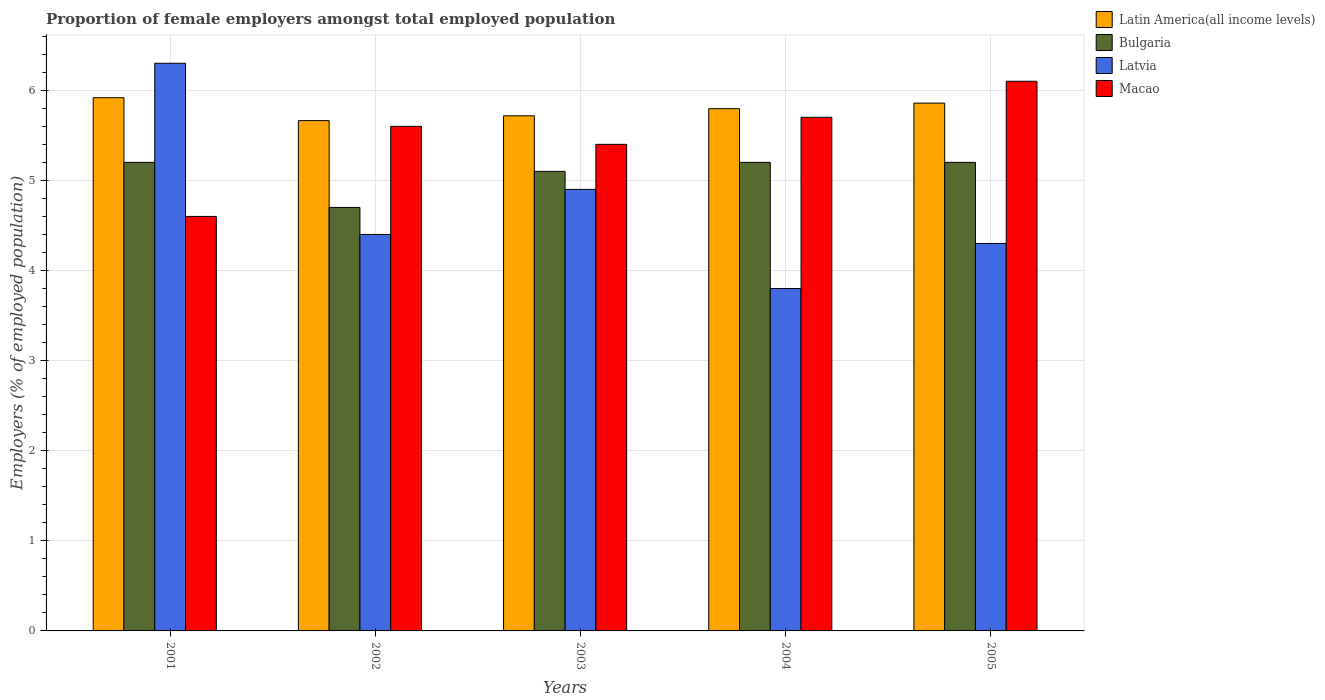Are the number of bars on each tick of the X-axis equal?
Give a very brief answer. Yes. In how many cases, is the number of bars for a given year not equal to the number of legend labels?
Make the answer very short. 0. What is the proportion of female employers in Bulgaria in 2003?
Offer a terse response. 5.1. Across all years, what is the maximum proportion of female employers in Latvia?
Keep it short and to the point. 6.3. Across all years, what is the minimum proportion of female employers in Latvia?
Provide a succinct answer. 3.8. In which year was the proportion of female employers in Bulgaria maximum?
Offer a terse response. 2001. In which year was the proportion of female employers in Latvia minimum?
Give a very brief answer. 2004. What is the total proportion of female employers in Macao in the graph?
Offer a very short reply. 27.4. What is the difference between the proportion of female employers in Latvia in 2005 and the proportion of female employers in Latin America(all income levels) in 2004?
Offer a very short reply. -1.5. What is the average proportion of female employers in Bulgaria per year?
Make the answer very short. 5.08. In the year 2002, what is the difference between the proportion of female employers in Macao and proportion of female employers in Latvia?
Your answer should be very brief. 1.2. In how many years, is the proportion of female employers in Latvia greater than 2.2 %?
Ensure brevity in your answer.  5. What is the ratio of the proportion of female employers in Macao in 2002 to that in 2004?
Keep it short and to the point. 0.98. What is the difference between the highest and the second highest proportion of female employers in Latin America(all income levels)?
Offer a terse response. 0.06. In how many years, is the proportion of female employers in Bulgaria greater than the average proportion of female employers in Bulgaria taken over all years?
Your answer should be very brief. 4. Is the sum of the proportion of female employers in Latin America(all income levels) in 2001 and 2004 greater than the maximum proportion of female employers in Macao across all years?
Your answer should be compact. Yes. What does the 1st bar from the right in 2001 represents?
Provide a short and direct response. Macao. Is it the case that in every year, the sum of the proportion of female employers in Latin America(all income levels) and proportion of female employers in Macao is greater than the proportion of female employers in Latvia?
Make the answer very short. Yes. How many bars are there?
Offer a terse response. 20. Are the values on the major ticks of Y-axis written in scientific E-notation?
Your response must be concise. No. Does the graph contain any zero values?
Offer a very short reply. No. Does the graph contain grids?
Provide a succinct answer. Yes. Where does the legend appear in the graph?
Your answer should be compact. Top right. What is the title of the graph?
Keep it short and to the point. Proportion of female employers amongst total employed population. What is the label or title of the Y-axis?
Provide a succinct answer. Employers (% of employed population). What is the Employers (% of employed population) of Latin America(all income levels) in 2001?
Ensure brevity in your answer.  5.92. What is the Employers (% of employed population) in Bulgaria in 2001?
Your answer should be very brief. 5.2. What is the Employers (% of employed population) of Latvia in 2001?
Keep it short and to the point. 6.3. What is the Employers (% of employed population) in Macao in 2001?
Offer a very short reply. 4.6. What is the Employers (% of employed population) of Latin America(all income levels) in 2002?
Provide a succinct answer. 5.66. What is the Employers (% of employed population) in Bulgaria in 2002?
Offer a very short reply. 4.7. What is the Employers (% of employed population) in Latvia in 2002?
Keep it short and to the point. 4.4. What is the Employers (% of employed population) in Macao in 2002?
Offer a very short reply. 5.6. What is the Employers (% of employed population) in Latin America(all income levels) in 2003?
Make the answer very short. 5.72. What is the Employers (% of employed population) of Bulgaria in 2003?
Ensure brevity in your answer.  5.1. What is the Employers (% of employed population) in Latvia in 2003?
Provide a succinct answer. 4.9. What is the Employers (% of employed population) of Macao in 2003?
Provide a succinct answer. 5.4. What is the Employers (% of employed population) in Latin America(all income levels) in 2004?
Provide a short and direct response. 5.8. What is the Employers (% of employed population) of Bulgaria in 2004?
Your answer should be compact. 5.2. What is the Employers (% of employed population) of Latvia in 2004?
Your answer should be very brief. 3.8. What is the Employers (% of employed population) of Macao in 2004?
Make the answer very short. 5.7. What is the Employers (% of employed population) in Latin America(all income levels) in 2005?
Offer a very short reply. 5.86. What is the Employers (% of employed population) of Bulgaria in 2005?
Offer a terse response. 5.2. What is the Employers (% of employed population) of Latvia in 2005?
Keep it short and to the point. 4.3. What is the Employers (% of employed population) of Macao in 2005?
Give a very brief answer. 6.1. Across all years, what is the maximum Employers (% of employed population) in Latin America(all income levels)?
Your answer should be very brief. 5.92. Across all years, what is the maximum Employers (% of employed population) in Bulgaria?
Give a very brief answer. 5.2. Across all years, what is the maximum Employers (% of employed population) in Latvia?
Ensure brevity in your answer.  6.3. Across all years, what is the maximum Employers (% of employed population) of Macao?
Make the answer very short. 6.1. Across all years, what is the minimum Employers (% of employed population) of Latin America(all income levels)?
Offer a very short reply. 5.66. Across all years, what is the minimum Employers (% of employed population) of Bulgaria?
Provide a short and direct response. 4.7. Across all years, what is the minimum Employers (% of employed population) in Latvia?
Give a very brief answer. 3.8. Across all years, what is the minimum Employers (% of employed population) of Macao?
Provide a short and direct response. 4.6. What is the total Employers (% of employed population) of Latin America(all income levels) in the graph?
Provide a short and direct response. 28.95. What is the total Employers (% of employed population) in Bulgaria in the graph?
Your answer should be very brief. 25.4. What is the total Employers (% of employed population) of Latvia in the graph?
Your response must be concise. 23.7. What is the total Employers (% of employed population) in Macao in the graph?
Your answer should be compact. 27.4. What is the difference between the Employers (% of employed population) in Latin America(all income levels) in 2001 and that in 2002?
Offer a terse response. 0.25. What is the difference between the Employers (% of employed population) in Bulgaria in 2001 and that in 2002?
Give a very brief answer. 0.5. What is the difference between the Employers (% of employed population) in Latvia in 2001 and that in 2002?
Provide a short and direct response. 1.9. What is the difference between the Employers (% of employed population) of Macao in 2001 and that in 2002?
Your answer should be very brief. -1. What is the difference between the Employers (% of employed population) in Latin America(all income levels) in 2001 and that in 2003?
Your response must be concise. 0.2. What is the difference between the Employers (% of employed population) in Bulgaria in 2001 and that in 2003?
Provide a short and direct response. 0.1. What is the difference between the Employers (% of employed population) in Macao in 2001 and that in 2003?
Provide a short and direct response. -0.8. What is the difference between the Employers (% of employed population) of Latin America(all income levels) in 2001 and that in 2004?
Provide a succinct answer. 0.12. What is the difference between the Employers (% of employed population) in Latin America(all income levels) in 2001 and that in 2005?
Your answer should be compact. 0.06. What is the difference between the Employers (% of employed population) of Latvia in 2001 and that in 2005?
Provide a short and direct response. 2. What is the difference between the Employers (% of employed population) of Latin America(all income levels) in 2002 and that in 2003?
Keep it short and to the point. -0.05. What is the difference between the Employers (% of employed population) in Bulgaria in 2002 and that in 2003?
Provide a short and direct response. -0.4. What is the difference between the Employers (% of employed population) of Latvia in 2002 and that in 2003?
Offer a terse response. -0.5. What is the difference between the Employers (% of employed population) in Macao in 2002 and that in 2003?
Keep it short and to the point. 0.2. What is the difference between the Employers (% of employed population) in Latin America(all income levels) in 2002 and that in 2004?
Give a very brief answer. -0.13. What is the difference between the Employers (% of employed population) in Bulgaria in 2002 and that in 2004?
Make the answer very short. -0.5. What is the difference between the Employers (% of employed population) of Macao in 2002 and that in 2004?
Give a very brief answer. -0.1. What is the difference between the Employers (% of employed population) in Latin America(all income levels) in 2002 and that in 2005?
Your answer should be very brief. -0.19. What is the difference between the Employers (% of employed population) in Bulgaria in 2002 and that in 2005?
Give a very brief answer. -0.5. What is the difference between the Employers (% of employed population) in Latvia in 2002 and that in 2005?
Make the answer very short. 0.1. What is the difference between the Employers (% of employed population) in Macao in 2002 and that in 2005?
Provide a short and direct response. -0.5. What is the difference between the Employers (% of employed population) of Latin America(all income levels) in 2003 and that in 2004?
Give a very brief answer. -0.08. What is the difference between the Employers (% of employed population) in Latvia in 2003 and that in 2004?
Make the answer very short. 1.1. What is the difference between the Employers (% of employed population) of Macao in 2003 and that in 2004?
Offer a very short reply. -0.3. What is the difference between the Employers (% of employed population) of Latin America(all income levels) in 2003 and that in 2005?
Offer a very short reply. -0.14. What is the difference between the Employers (% of employed population) in Bulgaria in 2003 and that in 2005?
Keep it short and to the point. -0.1. What is the difference between the Employers (% of employed population) of Macao in 2003 and that in 2005?
Keep it short and to the point. -0.7. What is the difference between the Employers (% of employed population) in Latin America(all income levels) in 2004 and that in 2005?
Your response must be concise. -0.06. What is the difference between the Employers (% of employed population) of Bulgaria in 2004 and that in 2005?
Make the answer very short. 0. What is the difference between the Employers (% of employed population) of Macao in 2004 and that in 2005?
Offer a very short reply. -0.4. What is the difference between the Employers (% of employed population) of Latin America(all income levels) in 2001 and the Employers (% of employed population) of Bulgaria in 2002?
Your answer should be very brief. 1.22. What is the difference between the Employers (% of employed population) in Latin America(all income levels) in 2001 and the Employers (% of employed population) in Latvia in 2002?
Your answer should be compact. 1.52. What is the difference between the Employers (% of employed population) of Latin America(all income levels) in 2001 and the Employers (% of employed population) of Macao in 2002?
Offer a very short reply. 0.32. What is the difference between the Employers (% of employed population) of Bulgaria in 2001 and the Employers (% of employed population) of Latvia in 2002?
Offer a very short reply. 0.8. What is the difference between the Employers (% of employed population) in Bulgaria in 2001 and the Employers (% of employed population) in Macao in 2002?
Provide a short and direct response. -0.4. What is the difference between the Employers (% of employed population) in Latvia in 2001 and the Employers (% of employed population) in Macao in 2002?
Offer a terse response. 0.7. What is the difference between the Employers (% of employed population) in Latin America(all income levels) in 2001 and the Employers (% of employed population) in Bulgaria in 2003?
Your answer should be very brief. 0.82. What is the difference between the Employers (% of employed population) of Latin America(all income levels) in 2001 and the Employers (% of employed population) of Latvia in 2003?
Keep it short and to the point. 1.02. What is the difference between the Employers (% of employed population) in Latin America(all income levels) in 2001 and the Employers (% of employed population) in Macao in 2003?
Your answer should be compact. 0.52. What is the difference between the Employers (% of employed population) in Latvia in 2001 and the Employers (% of employed population) in Macao in 2003?
Ensure brevity in your answer.  0.9. What is the difference between the Employers (% of employed population) in Latin America(all income levels) in 2001 and the Employers (% of employed population) in Bulgaria in 2004?
Make the answer very short. 0.72. What is the difference between the Employers (% of employed population) of Latin America(all income levels) in 2001 and the Employers (% of employed population) of Latvia in 2004?
Your response must be concise. 2.12. What is the difference between the Employers (% of employed population) in Latin America(all income levels) in 2001 and the Employers (% of employed population) in Macao in 2004?
Your answer should be compact. 0.22. What is the difference between the Employers (% of employed population) in Bulgaria in 2001 and the Employers (% of employed population) in Macao in 2004?
Make the answer very short. -0.5. What is the difference between the Employers (% of employed population) of Latin America(all income levels) in 2001 and the Employers (% of employed population) of Bulgaria in 2005?
Provide a succinct answer. 0.72. What is the difference between the Employers (% of employed population) in Latin America(all income levels) in 2001 and the Employers (% of employed population) in Latvia in 2005?
Offer a very short reply. 1.62. What is the difference between the Employers (% of employed population) of Latin America(all income levels) in 2001 and the Employers (% of employed population) of Macao in 2005?
Your answer should be compact. -0.18. What is the difference between the Employers (% of employed population) of Bulgaria in 2001 and the Employers (% of employed population) of Latvia in 2005?
Your answer should be compact. 0.9. What is the difference between the Employers (% of employed population) in Latvia in 2001 and the Employers (% of employed population) in Macao in 2005?
Your answer should be compact. 0.2. What is the difference between the Employers (% of employed population) in Latin America(all income levels) in 2002 and the Employers (% of employed population) in Bulgaria in 2003?
Offer a terse response. 0.56. What is the difference between the Employers (% of employed population) of Latin America(all income levels) in 2002 and the Employers (% of employed population) of Latvia in 2003?
Your answer should be very brief. 0.76. What is the difference between the Employers (% of employed population) in Latin America(all income levels) in 2002 and the Employers (% of employed population) in Macao in 2003?
Provide a short and direct response. 0.26. What is the difference between the Employers (% of employed population) in Bulgaria in 2002 and the Employers (% of employed population) in Latvia in 2003?
Your response must be concise. -0.2. What is the difference between the Employers (% of employed population) of Latin America(all income levels) in 2002 and the Employers (% of employed population) of Bulgaria in 2004?
Make the answer very short. 0.46. What is the difference between the Employers (% of employed population) of Latin America(all income levels) in 2002 and the Employers (% of employed population) of Latvia in 2004?
Keep it short and to the point. 1.86. What is the difference between the Employers (% of employed population) of Latin America(all income levels) in 2002 and the Employers (% of employed population) of Macao in 2004?
Offer a very short reply. -0.04. What is the difference between the Employers (% of employed population) of Bulgaria in 2002 and the Employers (% of employed population) of Latvia in 2004?
Your answer should be very brief. 0.9. What is the difference between the Employers (% of employed population) in Bulgaria in 2002 and the Employers (% of employed population) in Macao in 2004?
Offer a terse response. -1. What is the difference between the Employers (% of employed population) in Latvia in 2002 and the Employers (% of employed population) in Macao in 2004?
Your answer should be compact. -1.3. What is the difference between the Employers (% of employed population) in Latin America(all income levels) in 2002 and the Employers (% of employed population) in Bulgaria in 2005?
Your answer should be very brief. 0.46. What is the difference between the Employers (% of employed population) of Latin America(all income levels) in 2002 and the Employers (% of employed population) of Latvia in 2005?
Your answer should be very brief. 1.36. What is the difference between the Employers (% of employed population) in Latin America(all income levels) in 2002 and the Employers (% of employed population) in Macao in 2005?
Offer a very short reply. -0.44. What is the difference between the Employers (% of employed population) in Latvia in 2002 and the Employers (% of employed population) in Macao in 2005?
Ensure brevity in your answer.  -1.7. What is the difference between the Employers (% of employed population) of Latin America(all income levels) in 2003 and the Employers (% of employed population) of Bulgaria in 2004?
Provide a short and direct response. 0.52. What is the difference between the Employers (% of employed population) in Latin America(all income levels) in 2003 and the Employers (% of employed population) in Latvia in 2004?
Keep it short and to the point. 1.92. What is the difference between the Employers (% of employed population) in Latin America(all income levels) in 2003 and the Employers (% of employed population) in Macao in 2004?
Ensure brevity in your answer.  0.02. What is the difference between the Employers (% of employed population) of Bulgaria in 2003 and the Employers (% of employed population) of Latvia in 2004?
Provide a short and direct response. 1.3. What is the difference between the Employers (% of employed population) of Latin America(all income levels) in 2003 and the Employers (% of employed population) of Bulgaria in 2005?
Your answer should be compact. 0.52. What is the difference between the Employers (% of employed population) of Latin America(all income levels) in 2003 and the Employers (% of employed population) of Latvia in 2005?
Offer a terse response. 1.42. What is the difference between the Employers (% of employed population) in Latin America(all income levels) in 2003 and the Employers (% of employed population) in Macao in 2005?
Keep it short and to the point. -0.38. What is the difference between the Employers (% of employed population) of Latvia in 2003 and the Employers (% of employed population) of Macao in 2005?
Provide a succinct answer. -1.2. What is the difference between the Employers (% of employed population) of Latin America(all income levels) in 2004 and the Employers (% of employed population) of Bulgaria in 2005?
Offer a very short reply. 0.6. What is the difference between the Employers (% of employed population) of Latin America(all income levels) in 2004 and the Employers (% of employed population) of Latvia in 2005?
Make the answer very short. 1.5. What is the difference between the Employers (% of employed population) in Latin America(all income levels) in 2004 and the Employers (% of employed population) in Macao in 2005?
Your response must be concise. -0.3. What is the difference between the Employers (% of employed population) in Bulgaria in 2004 and the Employers (% of employed population) in Latvia in 2005?
Your answer should be compact. 0.9. What is the difference between the Employers (% of employed population) in Latvia in 2004 and the Employers (% of employed population) in Macao in 2005?
Your response must be concise. -2.3. What is the average Employers (% of employed population) of Latin America(all income levels) per year?
Give a very brief answer. 5.79. What is the average Employers (% of employed population) in Bulgaria per year?
Your answer should be very brief. 5.08. What is the average Employers (% of employed population) of Latvia per year?
Your answer should be compact. 4.74. What is the average Employers (% of employed population) of Macao per year?
Provide a succinct answer. 5.48. In the year 2001, what is the difference between the Employers (% of employed population) of Latin America(all income levels) and Employers (% of employed population) of Bulgaria?
Ensure brevity in your answer.  0.72. In the year 2001, what is the difference between the Employers (% of employed population) of Latin America(all income levels) and Employers (% of employed population) of Latvia?
Give a very brief answer. -0.38. In the year 2001, what is the difference between the Employers (% of employed population) of Latin America(all income levels) and Employers (% of employed population) of Macao?
Give a very brief answer. 1.32. In the year 2002, what is the difference between the Employers (% of employed population) of Latin America(all income levels) and Employers (% of employed population) of Bulgaria?
Offer a terse response. 0.96. In the year 2002, what is the difference between the Employers (% of employed population) in Latin America(all income levels) and Employers (% of employed population) in Latvia?
Offer a very short reply. 1.26. In the year 2002, what is the difference between the Employers (% of employed population) in Latin America(all income levels) and Employers (% of employed population) in Macao?
Provide a succinct answer. 0.06. In the year 2003, what is the difference between the Employers (% of employed population) of Latin America(all income levels) and Employers (% of employed population) of Bulgaria?
Keep it short and to the point. 0.62. In the year 2003, what is the difference between the Employers (% of employed population) in Latin America(all income levels) and Employers (% of employed population) in Latvia?
Keep it short and to the point. 0.82. In the year 2003, what is the difference between the Employers (% of employed population) of Latin America(all income levels) and Employers (% of employed population) of Macao?
Your response must be concise. 0.32. In the year 2003, what is the difference between the Employers (% of employed population) in Bulgaria and Employers (% of employed population) in Latvia?
Provide a short and direct response. 0.2. In the year 2003, what is the difference between the Employers (% of employed population) of Bulgaria and Employers (% of employed population) of Macao?
Your answer should be compact. -0.3. In the year 2004, what is the difference between the Employers (% of employed population) in Latin America(all income levels) and Employers (% of employed population) in Bulgaria?
Provide a succinct answer. 0.6. In the year 2004, what is the difference between the Employers (% of employed population) in Latin America(all income levels) and Employers (% of employed population) in Latvia?
Your answer should be compact. 2. In the year 2004, what is the difference between the Employers (% of employed population) in Latin America(all income levels) and Employers (% of employed population) in Macao?
Keep it short and to the point. 0.1. In the year 2005, what is the difference between the Employers (% of employed population) of Latin America(all income levels) and Employers (% of employed population) of Bulgaria?
Your response must be concise. 0.66. In the year 2005, what is the difference between the Employers (% of employed population) of Latin America(all income levels) and Employers (% of employed population) of Latvia?
Ensure brevity in your answer.  1.56. In the year 2005, what is the difference between the Employers (% of employed population) in Latin America(all income levels) and Employers (% of employed population) in Macao?
Provide a succinct answer. -0.24. In the year 2005, what is the difference between the Employers (% of employed population) of Bulgaria and Employers (% of employed population) of Macao?
Provide a short and direct response. -0.9. In the year 2005, what is the difference between the Employers (% of employed population) of Latvia and Employers (% of employed population) of Macao?
Your response must be concise. -1.8. What is the ratio of the Employers (% of employed population) in Latin America(all income levels) in 2001 to that in 2002?
Ensure brevity in your answer.  1.04. What is the ratio of the Employers (% of employed population) of Bulgaria in 2001 to that in 2002?
Offer a very short reply. 1.11. What is the ratio of the Employers (% of employed population) in Latvia in 2001 to that in 2002?
Provide a succinct answer. 1.43. What is the ratio of the Employers (% of employed population) of Macao in 2001 to that in 2002?
Your response must be concise. 0.82. What is the ratio of the Employers (% of employed population) of Latin America(all income levels) in 2001 to that in 2003?
Your answer should be very brief. 1.04. What is the ratio of the Employers (% of employed population) of Bulgaria in 2001 to that in 2003?
Your answer should be very brief. 1.02. What is the ratio of the Employers (% of employed population) in Macao in 2001 to that in 2003?
Keep it short and to the point. 0.85. What is the ratio of the Employers (% of employed population) in Latin America(all income levels) in 2001 to that in 2004?
Provide a short and direct response. 1.02. What is the ratio of the Employers (% of employed population) of Latvia in 2001 to that in 2004?
Make the answer very short. 1.66. What is the ratio of the Employers (% of employed population) of Macao in 2001 to that in 2004?
Provide a short and direct response. 0.81. What is the ratio of the Employers (% of employed population) of Latin America(all income levels) in 2001 to that in 2005?
Your response must be concise. 1.01. What is the ratio of the Employers (% of employed population) in Bulgaria in 2001 to that in 2005?
Your answer should be very brief. 1. What is the ratio of the Employers (% of employed population) of Latvia in 2001 to that in 2005?
Keep it short and to the point. 1.47. What is the ratio of the Employers (% of employed population) of Macao in 2001 to that in 2005?
Make the answer very short. 0.75. What is the ratio of the Employers (% of employed population) in Bulgaria in 2002 to that in 2003?
Keep it short and to the point. 0.92. What is the ratio of the Employers (% of employed population) of Latvia in 2002 to that in 2003?
Your answer should be very brief. 0.9. What is the ratio of the Employers (% of employed population) in Macao in 2002 to that in 2003?
Provide a succinct answer. 1.04. What is the ratio of the Employers (% of employed population) of Latin America(all income levels) in 2002 to that in 2004?
Provide a short and direct response. 0.98. What is the ratio of the Employers (% of employed population) in Bulgaria in 2002 to that in 2004?
Ensure brevity in your answer.  0.9. What is the ratio of the Employers (% of employed population) in Latvia in 2002 to that in 2004?
Ensure brevity in your answer.  1.16. What is the ratio of the Employers (% of employed population) in Macao in 2002 to that in 2004?
Your response must be concise. 0.98. What is the ratio of the Employers (% of employed population) in Latin America(all income levels) in 2002 to that in 2005?
Provide a short and direct response. 0.97. What is the ratio of the Employers (% of employed population) in Bulgaria in 2002 to that in 2005?
Give a very brief answer. 0.9. What is the ratio of the Employers (% of employed population) in Latvia in 2002 to that in 2005?
Offer a very short reply. 1.02. What is the ratio of the Employers (% of employed population) in Macao in 2002 to that in 2005?
Offer a terse response. 0.92. What is the ratio of the Employers (% of employed population) in Latin America(all income levels) in 2003 to that in 2004?
Provide a short and direct response. 0.99. What is the ratio of the Employers (% of employed population) in Bulgaria in 2003 to that in 2004?
Offer a very short reply. 0.98. What is the ratio of the Employers (% of employed population) in Latvia in 2003 to that in 2004?
Offer a very short reply. 1.29. What is the ratio of the Employers (% of employed population) in Latin America(all income levels) in 2003 to that in 2005?
Your response must be concise. 0.98. What is the ratio of the Employers (% of employed population) in Bulgaria in 2003 to that in 2005?
Your answer should be very brief. 0.98. What is the ratio of the Employers (% of employed population) of Latvia in 2003 to that in 2005?
Give a very brief answer. 1.14. What is the ratio of the Employers (% of employed population) in Macao in 2003 to that in 2005?
Ensure brevity in your answer.  0.89. What is the ratio of the Employers (% of employed population) in Latin America(all income levels) in 2004 to that in 2005?
Your response must be concise. 0.99. What is the ratio of the Employers (% of employed population) of Latvia in 2004 to that in 2005?
Keep it short and to the point. 0.88. What is the ratio of the Employers (% of employed population) in Macao in 2004 to that in 2005?
Keep it short and to the point. 0.93. What is the difference between the highest and the second highest Employers (% of employed population) of Latin America(all income levels)?
Offer a terse response. 0.06. What is the difference between the highest and the second highest Employers (% of employed population) of Bulgaria?
Provide a succinct answer. 0. What is the difference between the highest and the second highest Employers (% of employed population) in Macao?
Ensure brevity in your answer.  0.4. What is the difference between the highest and the lowest Employers (% of employed population) of Latin America(all income levels)?
Make the answer very short. 0.25. What is the difference between the highest and the lowest Employers (% of employed population) in Macao?
Provide a short and direct response. 1.5. 